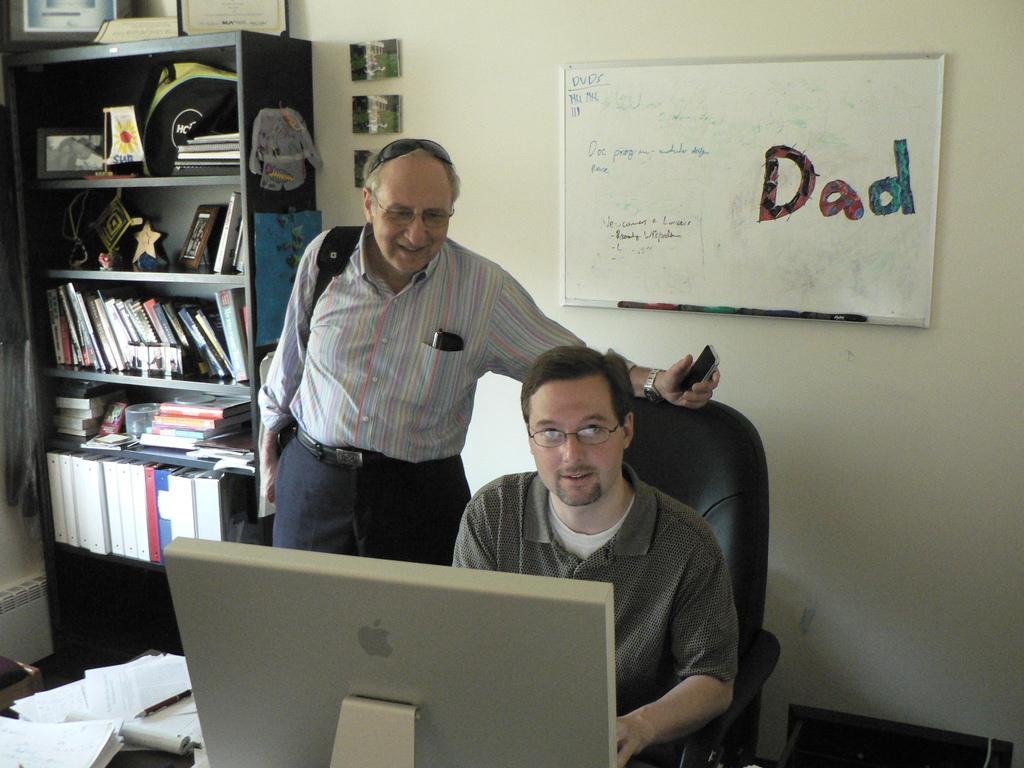Please provide a concise description of this image. In the picture we can see an inside view of the office with a man sitting on the chair near the desk and another man standing beside him on the desk and we can see a computer and besides, we can see some papers on the desk and in the background, we can see a rack with books, and something placed in it and besides we can see a wall with a board which is white in color with some things written on it. 